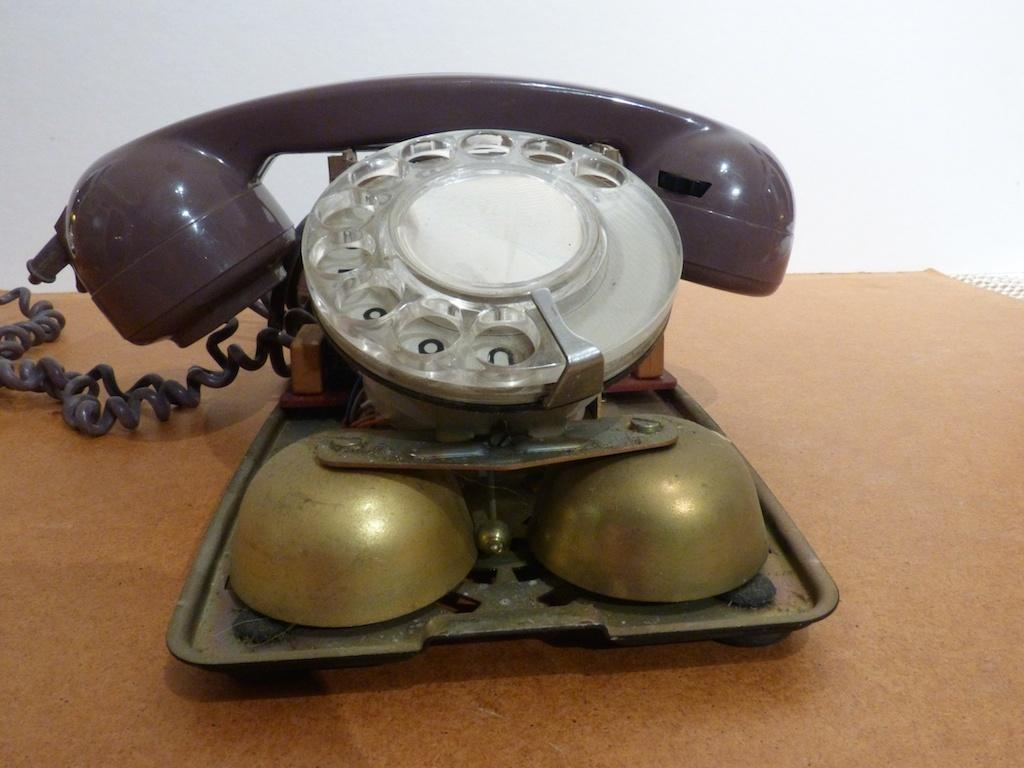What type of object is the main subject in the image? There is an old telephone in the image. What other items are visible in the image? There are two bells in gold color in the image. How are the bells related to the old telephone? The bells are attached to the old telephone. What is the surface on which the telephone and bells are placed? The telephone and bells are on a wooden board. What type of machine is used to process the flesh in the image? There is no machine or flesh present in the image; it features an old telephone with bells attached to it on a wooden board. 